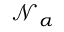<formula> <loc_0><loc_0><loc_500><loc_500>\mathcal { N } _ { \alpha }</formula> 